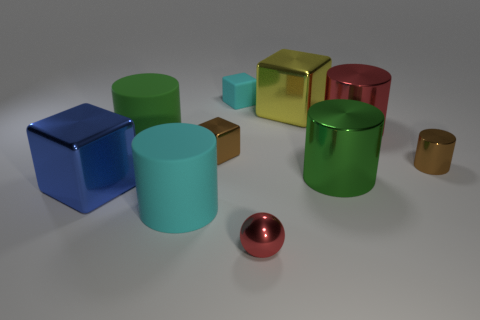Subtract 2 cylinders. How many cylinders are left? 3 Subtract all cyan cylinders. How many cylinders are left? 4 Subtract all big green metal cylinders. How many cylinders are left? 4 Subtract all gray blocks. Subtract all red spheres. How many blocks are left? 4 Subtract all blocks. How many objects are left? 6 Add 2 tiny brown cylinders. How many tiny brown cylinders are left? 3 Add 7 big brown shiny cylinders. How many big brown shiny cylinders exist? 7 Subtract 0 gray cylinders. How many objects are left? 10 Subtract all tiny brown cubes. Subtract all blue blocks. How many objects are left? 8 